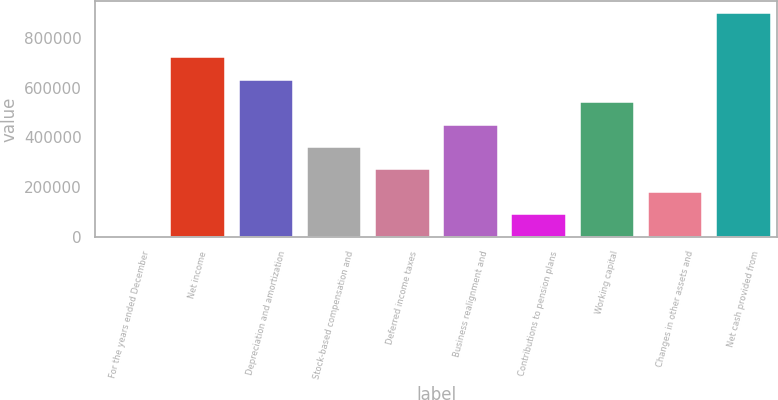<chart> <loc_0><loc_0><loc_500><loc_500><bar_chart><fcel>For the years ended December<fcel>Net income<fcel>Depreciation and amortization<fcel>Stock-based compensation and<fcel>Deferred income taxes<fcel>Business realignment and<fcel>Contributions to pension plans<fcel>Working capital<fcel>Changes in other assets and<fcel>Net cash provided from<nl><fcel>2010<fcel>721540<fcel>631599<fcel>361775<fcel>271834<fcel>451716<fcel>91951.3<fcel>541658<fcel>181893<fcel>901423<nl></chart> 